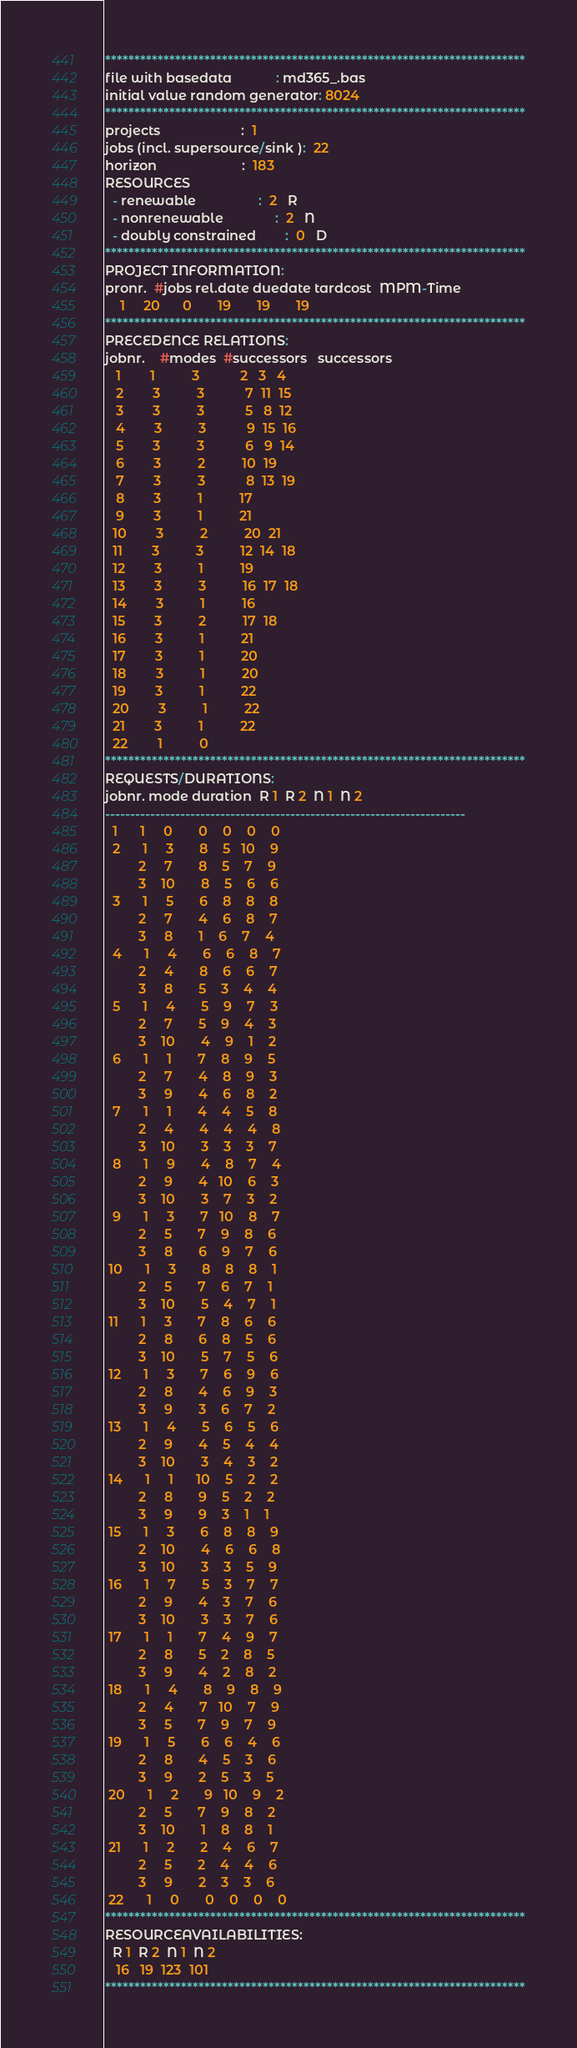Convert code to text. <code><loc_0><loc_0><loc_500><loc_500><_ObjectiveC_>************************************************************************
file with basedata            : md365_.bas
initial value random generator: 8024
************************************************************************
projects                      :  1
jobs (incl. supersource/sink ):  22
horizon                       :  183
RESOURCES
  - renewable                 :  2   R
  - nonrenewable              :  2   N
  - doubly constrained        :  0   D
************************************************************************
PROJECT INFORMATION:
pronr.  #jobs rel.date duedate tardcost  MPM-Time
    1     20      0       19       19       19
************************************************************************
PRECEDENCE RELATIONS:
jobnr.    #modes  #successors   successors
   1        1          3           2   3   4
   2        3          3           7  11  15
   3        3          3           5   8  12
   4        3          3           9  15  16
   5        3          3           6   9  14
   6        3          2          10  19
   7        3          3           8  13  19
   8        3          1          17
   9        3          1          21
  10        3          2          20  21
  11        3          3          12  14  18
  12        3          1          19
  13        3          3          16  17  18
  14        3          1          16
  15        3          2          17  18
  16        3          1          21
  17        3          1          20
  18        3          1          20
  19        3          1          22
  20        3          1          22
  21        3          1          22
  22        1          0        
************************************************************************
REQUESTS/DURATIONS:
jobnr. mode duration  R 1  R 2  N 1  N 2
------------------------------------------------------------------------
  1      1     0       0    0    0    0
  2      1     3       8    5   10    9
         2     7       8    5    7    9
         3    10       8    5    6    6
  3      1     5       6    8    8    8
         2     7       4    6    8    7
         3     8       1    6    7    4
  4      1     4       6    6    8    7
         2     4       8    6    6    7
         3     8       5    3    4    4
  5      1     4       5    9    7    3
         2     7       5    9    4    3
         3    10       4    9    1    2
  6      1     1       7    8    9    5
         2     7       4    8    9    3
         3     9       4    6    8    2
  7      1     1       4    4    5    8
         2     4       4    4    4    8
         3    10       3    3    3    7
  8      1     9       4    8    7    4
         2     9       4   10    6    3
         3    10       3    7    3    2
  9      1     3       7   10    8    7
         2     5       7    9    8    6
         3     8       6    9    7    6
 10      1     3       8    8    8    1
         2     5       7    6    7    1
         3    10       5    4    7    1
 11      1     3       7    8    6    6
         2     8       6    8    5    6
         3    10       5    7    5    6
 12      1     3       7    6    9    6
         2     8       4    6    9    3
         3     9       3    6    7    2
 13      1     4       5    6    5    6
         2     9       4    5    4    4
         3    10       3    4    3    2
 14      1     1      10    5    2    2
         2     8       9    5    2    2
         3     9       9    3    1    1
 15      1     3       6    8    8    9
         2    10       4    6    6    8
         3    10       3    3    5    9
 16      1     7       5    3    7    7
         2     9       4    3    7    6
         3    10       3    3    7    6
 17      1     1       7    4    9    7
         2     8       5    2    8    5
         3     9       4    2    8    2
 18      1     4       8    9    8    9
         2     4       7   10    7    9
         3     5       7    9    7    9
 19      1     5       6    6    4    6
         2     8       4    5    3    6
         3     9       2    5    3    5
 20      1     2       9   10    9    2
         2     5       7    9    8    2
         3    10       1    8    8    1
 21      1     2       2    4    6    7
         2     5       2    4    4    6
         3     9       2    3    3    6
 22      1     0       0    0    0    0
************************************************************************
RESOURCEAVAILABILITIES:
  R 1  R 2  N 1  N 2
   16   19  123  101
************************************************************************
</code> 